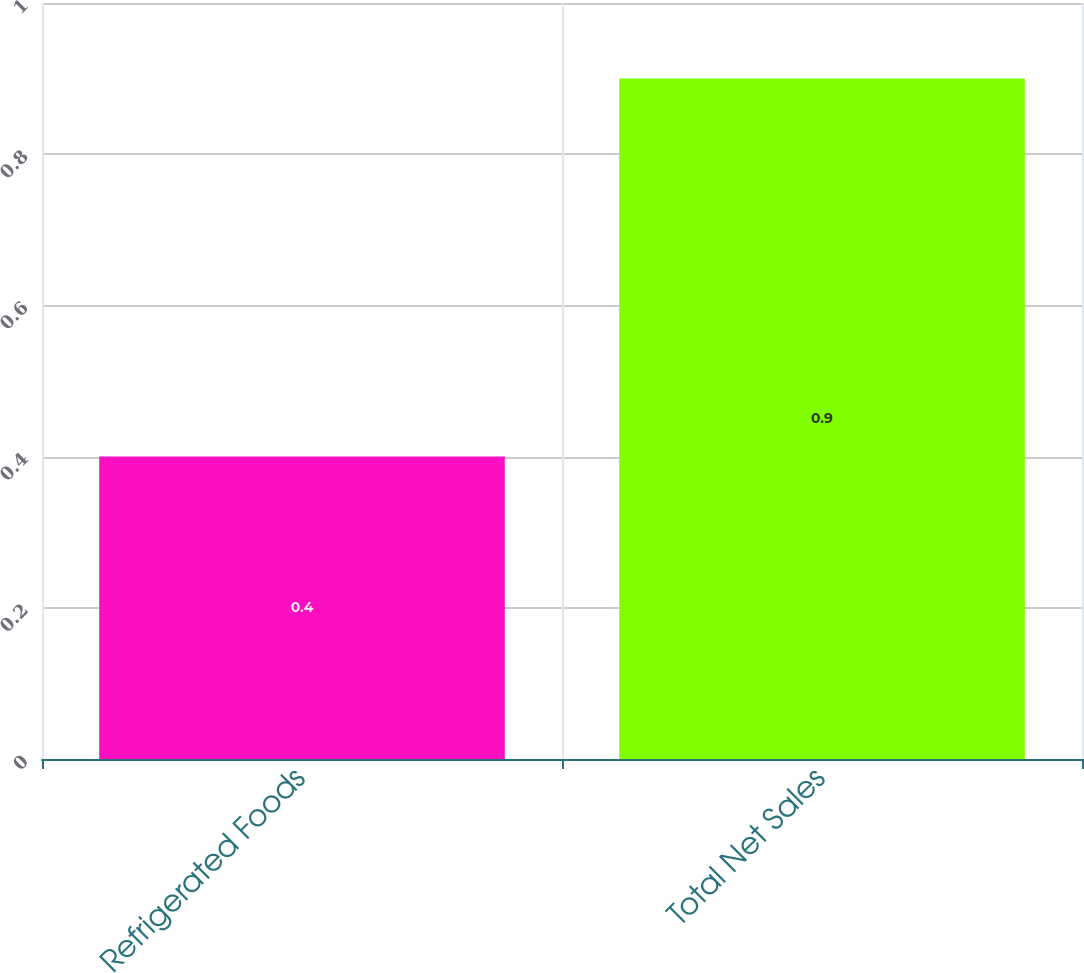Convert chart. <chart><loc_0><loc_0><loc_500><loc_500><bar_chart><fcel>Refrigerated Foods<fcel>Total Net Sales<nl><fcel>0.4<fcel>0.9<nl></chart> 